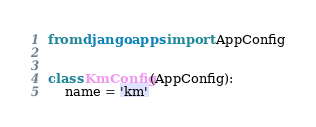Convert code to text. <code><loc_0><loc_0><loc_500><loc_500><_Python_>from django.apps import AppConfig


class KmConfig(AppConfig):
    name = 'km'
</code> 